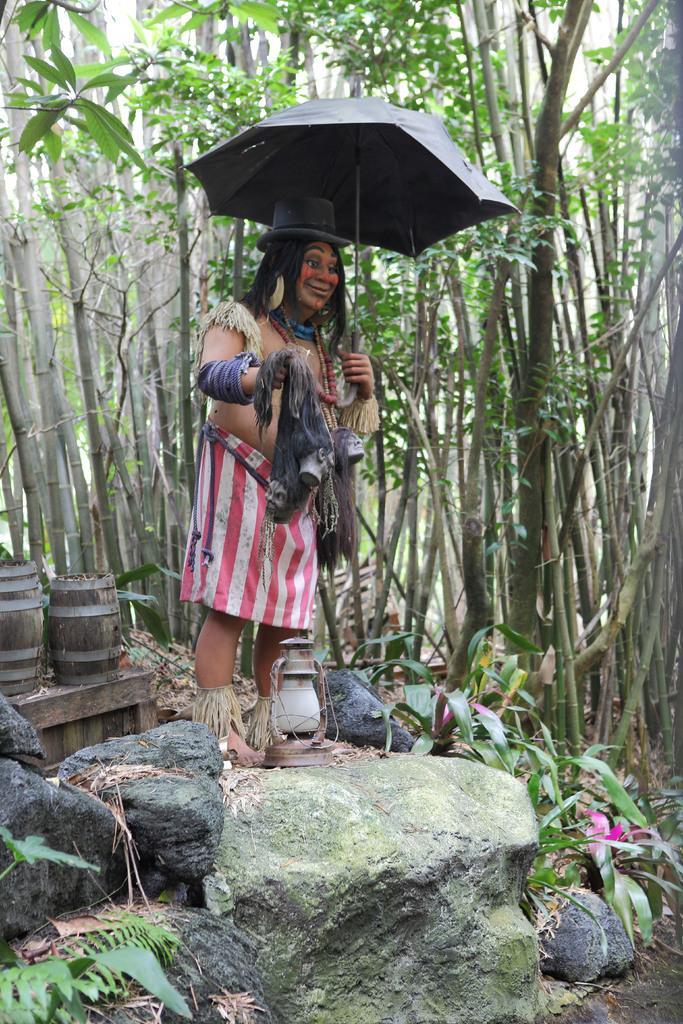Describe this image in one or two sentences. In the center of the image we can see a statue holding an umbrella and a lamp is placed on the ground. In the foreground we can see some rocks. On the left side of the image we can see two barrels placed on the surface. In the background, we can see a group of trees, plants and the sky. 